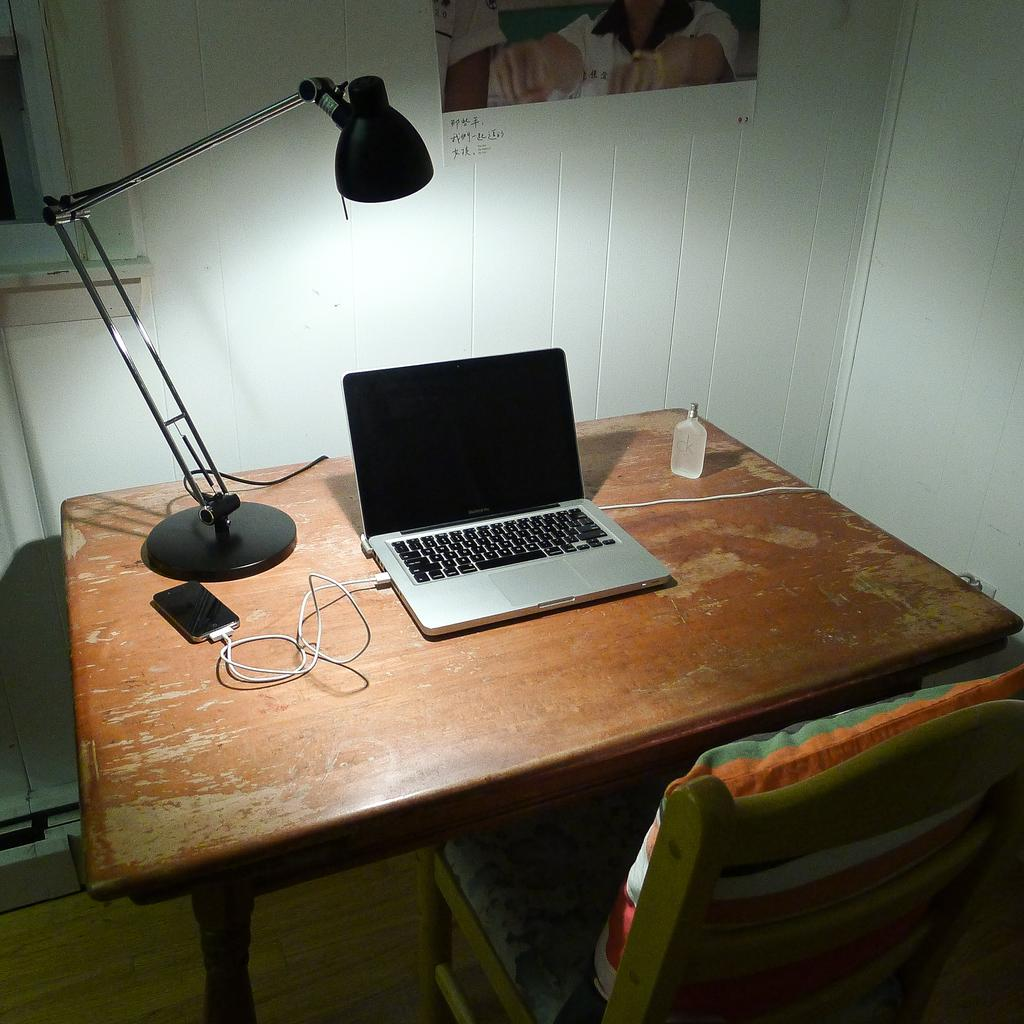What electronic device is on the table in the image? There is a laptop on the table in the image. What can be seen in the image that provides illumination? There is a light in the image. What other electronic device is visible in the image? There is a mobile phone in the image. How are the laptop and mobile phone related in the image? The mobile phone is attached to the laptop. Can you see the moon in the image? No, the moon is not present in the image. What boundary is visible in the image? There is no boundary visible in the image. 